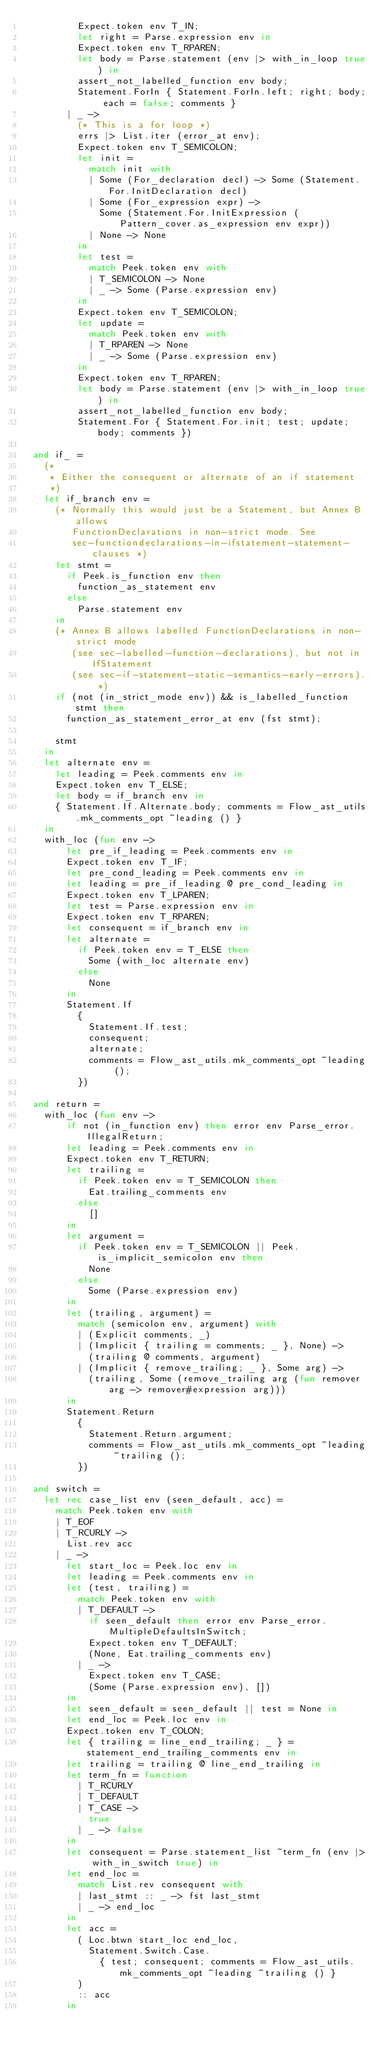Convert code to text. <code><loc_0><loc_0><loc_500><loc_500><_OCaml_>          Expect.token env T_IN;
          let right = Parse.expression env in
          Expect.token env T_RPAREN;
          let body = Parse.statement (env |> with_in_loop true) in
          assert_not_labelled_function env body;
          Statement.ForIn { Statement.ForIn.left; right; body; each = false; comments }
        | _ ->
          (* This is a for loop *)
          errs |> List.iter (error_at env);
          Expect.token env T_SEMICOLON;
          let init =
            match init with
            | Some (For_declaration decl) -> Some (Statement.For.InitDeclaration decl)
            | Some (For_expression expr) ->
              Some (Statement.For.InitExpression (Pattern_cover.as_expression env expr))
            | None -> None
          in
          let test =
            match Peek.token env with
            | T_SEMICOLON -> None
            | _ -> Some (Parse.expression env)
          in
          Expect.token env T_SEMICOLON;
          let update =
            match Peek.token env with
            | T_RPAREN -> None
            | _ -> Some (Parse.expression env)
          in
          Expect.token env T_RPAREN;
          let body = Parse.statement (env |> with_in_loop true) in
          assert_not_labelled_function env body;
          Statement.For { Statement.For.init; test; update; body; comments })

  and if_ =
    (*
     * Either the consequent or alternate of an if statement
     *)
    let if_branch env =
      (* Normally this would just be a Statement, but Annex B allows
         FunctionDeclarations in non-strict mode. See
         sec-functiondeclarations-in-ifstatement-statement-clauses *)
      let stmt =
        if Peek.is_function env then
          function_as_statement env
        else
          Parse.statement env
      in
      (* Annex B allows labelled FunctionDeclarations in non-strict mode
         (see sec-labelled-function-declarations), but not in IfStatement
         (see sec-if-statement-static-semantics-early-errors). *)
      if (not (in_strict_mode env)) && is_labelled_function stmt then
        function_as_statement_error_at env (fst stmt);

      stmt
    in
    let alternate env =
      let leading = Peek.comments env in
      Expect.token env T_ELSE;
      let body = if_branch env in
      { Statement.If.Alternate.body; comments = Flow_ast_utils.mk_comments_opt ~leading () }
    in
    with_loc (fun env ->
        let pre_if_leading = Peek.comments env in
        Expect.token env T_IF;
        let pre_cond_leading = Peek.comments env in
        let leading = pre_if_leading @ pre_cond_leading in
        Expect.token env T_LPAREN;
        let test = Parse.expression env in
        Expect.token env T_RPAREN;
        let consequent = if_branch env in
        let alternate =
          if Peek.token env = T_ELSE then
            Some (with_loc alternate env)
          else
            None
        in
        Statement.If
          {
            Statement.If.test;
            consequent;
            alternate;
            comments = Flow_ast_utils.mk_comments_opt ~leading ();
          })

  and return =
    with_loc (fun env ->
        if not (in_function env) then error env Parse_error.IllegalReturn;
        let leading = Peek.comments env in
        Expect.token env T_RETURN;
        let trailing =
          if Peek.token env = T_SEMICOLON then
            Eat.trailing_comments env
          else
            []
        in
        let argument =
          if Peek.token env = T_SEMICOLON || Peek.is_implicit_semicolon env then
            None
          else
            Some (Parse.expression env)
        in
        let (trailing, argument) =
          match (semicolon env, argument) with
          | (Explicit comments, _)
          | (Implicit { trailing = comments; _ }, None) ->
            (trailing @ comments, argument)
          | (Implicit { remove_trailing; _ }, Some arg) ->
            (trailing, Some (remove_trailing arg (fun remover arg -> remover#expression arg)))
        in
        Statement.Return
          {
            Statement.Return.argument;
            comments = Flow_ast_utils.mk_comments_opt ~leading ~trailing ();
          })

  and switch =
    let rec case_list env (seen_default, acc) =
      match Peek.token env with
      | T_EOF
      | T_RCURLY ->
        List.rev acc
      | _ ->
        let start_loc = Peek.loc env in
        let leading = Peek.comments env in
        let (test, trailing) =
          match Peek.token env with
          | T_DEFAULT ->
            if seen_default then error env Parse_error.MultipleDefaultsInSwitch;
            Expect.token env T_DEFAULT;
            (None, Eat.trailing_comments env)
          | _ ->
            Expect.token env T_CASE;
            (Some (Parse.expression env), [])
        in
        let seen_default = seen_default || test = None in
        let end_loc = Peek.loc env in
        Expect.token env T_COLON;
        let { trailing = line_end_trailing; _ } = statement_end_trailing_comments env in
        let trailing = trailing @ line_end_trailing in
        let term_fn = function
          | T_RCURLY
          | T_DEFAULT
          | T_CASE ->
            true
          | _ -> false
        in
        let consequent = Parse.statement_list ~term_fn (env |> with_in_switch true) in
        let end_loc =
          match List.rev consequent with
          | last_stmt :: _ -> fst last_stmt
          | _ -> end_loc
        in
        let acc =
          ( Loc.btwn start_loc end_loc,
            Statement.Switch.Case.
              { test; consequent; comments = Flow_ast_utils.mk_comments_opt ~leading ~trailing () }
          )
          :: acc
        in</code> 